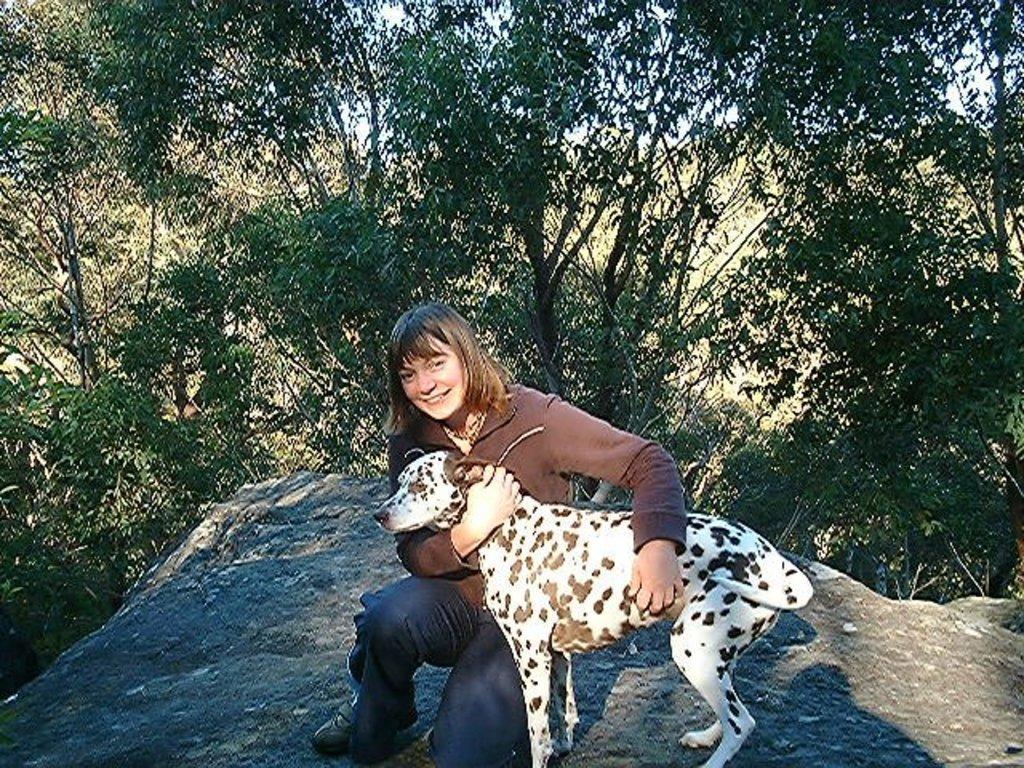Please provide a concise description of this image. In this image i can see a woman sitting and holding a dog. In the background i can see trees, sky and a rock. 